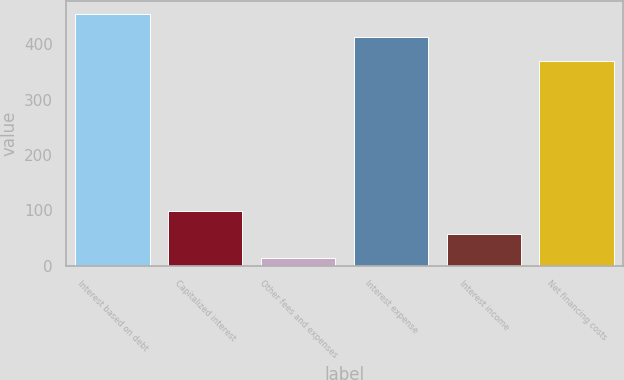Convert chart to OTSL. <chart><loc_0><loc_0><loc_500><loc_500><bar_chart><fcel>Interest based on debt<fcel>Capitalized interest<fcel>Other fees and expenses<fcel>Interest expense<fcel>Interest income<fcel>Net financing costs<nl><fcel>455.2<fcel>99.2<fcel>14<fcel>412.6<fcel>56.6<fcel>370<nl></chart> 